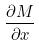Convert formula to latex. <formula><loc_0><loc_0><loc_500><loc_500>\frac { \partial M } { \partial x }</formula> 